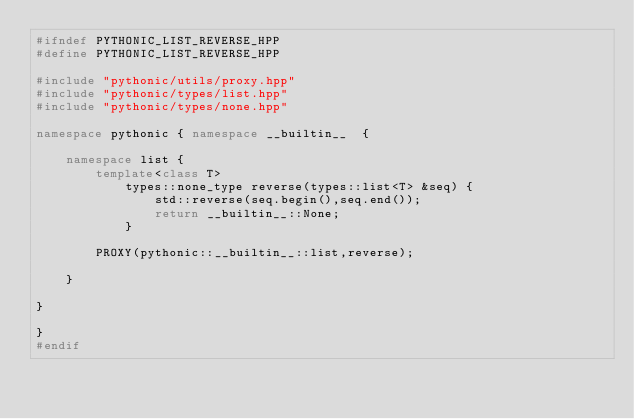Convert code to text. <code><loc_0><loc_0><loc_500><loc_500><_C++_>#ifndef PYTHONIC_LIST_REVERSE_HPP
#define PYTHONIC_LIST_REVERSE_HPP

#include "pythonic/utils/proxy.hpp"
#include "pythonic/types/list.hpp"
#include "pythonic/types/none.hpp"

namespace pythonic { namespace __builtin__  {

    namespace list {
        template<class T>
            types::none_type reverse(types::list<T> &seq) {
                std::reverse(seq.begin(),seq.end());
                return __builtin__::None;
            }

        PROXY(pythonic::__builtin__::list,reverse);

    }

}

}
#endif

</code> 